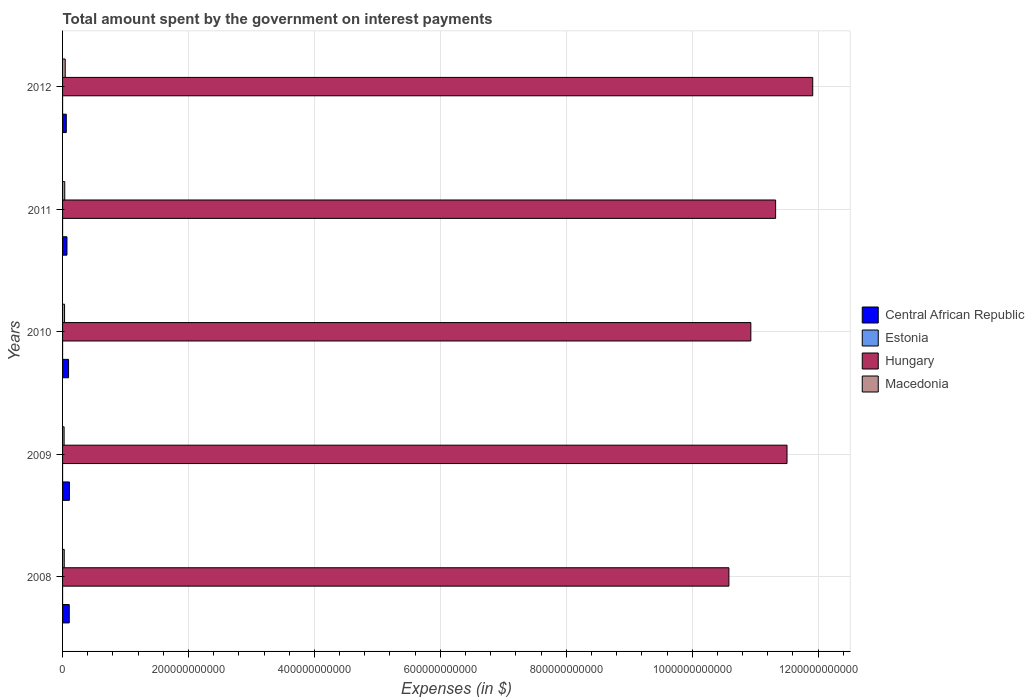Are the number of bars per tick equal to the number of legend labels?
Ensure brevity in your answer.  Yes. Are the number of bars on each tick of the Y-axis equal?
Your answer should be very brief. Yes. How many bars are there on the 2nd tick from the bottom?
Your answer should be very brief. 4. What is the label of the 1st group of bars from the top?
Your answer should be compact. 2012. In how many cases, is the number of bars for a given year not equal to the number of legend labels?
Provide a short and direct response. 0. What is the amount spent on interest payments by the government in Macedonia in 2011?
Offer a very short reply. 3.47e+09. Across all years, what is the maximum amount spent on interest payments by the government in Estonia?
Keep it short and to the point. 1.70e+07. Across all years, what is the minimum amount spent on interest payments by the government in Macedonia?
Give a very brief answer. 2.44e+09. In which year was the amount spent on interest payments by the government in Central African Republic minimum?
Offer a very short reply. 2012. What is the total amount spent on interest payments by the government in Hungary in the graph?
Your answer should be compact. 5.63e+12. What is the difference between the amount spent on interest payments by the government in Central African Republic in 2010 and that in 2012?
Provide a short and direct response. 3.59e+09. What is the difference between the amount spent on interest payments by the government in Central African Republic in 2010 and the amount spent on interest payments by the government in Macedonia in 2008?
Your answer should be compact. 6.87e+09. What is the average amount spent on interest payments by the government in Central African Republic per year?
Offer a very short reply. 8.77e+09. In the year 2010, what is the difference between the amount spent on interest payments by the government in Estonia and amount spent on interest payments by the government in Macedonia?
Provide a short and direct response. -3.17e+09. What is the ratio of the amount spent on interest payments by the government in Macedonia in 2008 to that in 2010?
Make the answer very short. 0.83. Is the amount spent on interest payments by the government in Macedonia in 2010 less than that in 2012?
Your answer should be compact. Yes. Is the difference between the amount spent on interest payments by the government in Estonia in 2010 and 2011 greater than the difference between the amount spent on interest payments by the government in Macedonia in 2010 and 2011?
Provide a short and direct response. Yes. What is the difference between the highest and the second highest amount spent on interest payments by the government in Central African Republic?
Provide a short and direct response. 2.10e+08. What is the difference between the highest and the lowest amount spent on interest payments by the government in Hungary?
Offer a terse response. 1.33e+11. In how many years, is the amount spent on interest payments by the government in Macedonia greater than the average amount spent on interest payments by the government in Macedonia taken over all years?
Give a very brief answer. 2. Is the sum of the amount spent on interest payments by the government in Central African Republic in 2008 and 2010 greater than the maximum amount spent on interest payments by the government in Macedonia across all years?
Offer a very short reply. Yes. What does the 2nd bar from the top in 2009 represents?
Your response must be concise. Hungary. What does the 4th bar from the bottom in 2010 represents?
Give a very brief answer. Macedonia. What is the difference between two consecutive major ticks on the X-axis?
Your answer should be compact. 2.00e+11. Does the graph contain any zero values?
Your answer should be very brief. No. How many legend labels are there?
Your answer should be very brief. 4. What is the title of the graph?
Offer a terse response. Total amount spent by the government on interest payments. Does "Denmark" appear as one of the legend labels in the graph?
Your response must be concise. No. What is the label or title of the X-axis?
Provide a succinct answer. Expenses (in $). What is the Expenses (in $) of Central African Republic in 2008?
Offer a very short reply. 1.06e+1. What is the Expenses (in $) of Estonia in 2008?
Provide a short and direct response. 1.32e+07. What is the Expenses (in $) in Hungary in 2008?
Provide a short and direct response. 1.06e+12. What is the Expenses (in $) in Macedonia in 2008?
Offer a very short reply. 2.65e+09. What is the Expenses (in $) of Central African Republic in 2009?
Ensure brevity in your answer.  1.08e+1. What is the Expenses (in $) of Estonia in 2009?
Your answer should be compact. 1.28e+07. What is the Expenses (in $) of Hungary in 2009?
Make the answer very short. 1.15e+12. What is the Expenses (in $) in Macedonia in 2009?
Provide a short and direct response. 2.44e+09. What is the Expenses (in $) of Central African Republic in 2010?
Provide a short and direct response. 9.51e+09. What is the Expenses (in $) of Estonia in 2010?
Provide a short and direct response. 8.20e+06. What is the Expenses (in $) in Hungary in 2010?
Give a very brief answer. 1.09e+12. What is the Expenses (in $) of Macedonia in 2010?
Your response must be concise. 3.17e+09. What is the Expenses (in $) of Central African Republic in 2011?
Give a very brief answer. 6.98e+09. What is the Expenses (in $) of Estonia in 2011?
Make the answer very short. 1.07e+07. What is the Expenses (in $) in Hungary in 2011?
Give a very brief answer. 1.13e+12. What is the Expenses (in $) of Macedonia in 2011?
Provide a short and direct response. 3.47e+09. What is the Expenses (in $) in Central African Republic in 2012?
Make the answer very short. 5.92e+09. What is the Expenses (in $) of Estonia in 2012?
Offer a very short reply. 1.70e+07. What is the Expenses (in $) in Hungary in 2012?
Provide a succinct answer. 1.19e+12. What is the Expenses (in $) of Macedonia in 2012?
Provide a succinct answer. 4.22e+09. Across all years, what is the maximum Expenses (in $) in Central African Republic?
Give a very brief answer. 1.08e+1. Across all years, what is the maximum Expenses (in $) in Estonia?
Ensure brevity in your answer.  1.70e+07. Across all years, what is the maximum Expenses (in $) in Hungary?
Provide a succinct answer. 1.19e+12. Across all years, what is the maximum Expenses (in $) in Macedonia?
Provide a short and direct response. 4.22e+09. Across all years, what is the minimum Expenses (in $) of Central African Republic?
Your answer should be very brief. 5.92e+09. Across all years, what is the minimum Expenses (in $) of Estonia?
Keep it short and to the point. 8.20e+06. Across all years, what is the minimum Expenses (in $) in Hungary?
Provide a short and direct response. 1.06e+12. Across all years, what is the minimum Expenses (in $) of Macedonia?
Provide a short and direct response. 2.44e+09. What is the total Expenses (in $) of Central African Republic in the graph?
Keep it short and to the point. 4.39e+1. What is the total Expenses (in $) of Estonia in the graph?
Your answer should be very brief. 6.19e+07. What is the total Expenses (in $) of Hungary in the graph?
Keep it short and to the point. 5.63e+12. What is the total Expenses (in $) of Macedonia in the graph?
Your answer should be compact. 1.60e+1. What is the difference between the Expenses (in $) in Central African Republic in 2008 and that in 2009?
Your answer should be compact. -2.10e+08. What is the difference between the Expenses (in $) in Hungary in 2008 and that in 2009?
Ensure brevity in your answer.  -9.23e+1. What is the difference between the Expenses (in $) in Macedonia in 2008 and that in 2009?
Your answer should be very brief. 2.01e+08. What is the difference between the Expenses (in $) in Central African Republic in 2008 and that in 2010?
Keep it short and to the point. 1.11e+09. What is the difference between the Expenses (in $) of Hungary in 2008 and that in 2010?
Your answer should be compact. -3.49e+1. What is the difference between the Expenses (in $) of Macedonia in 2008 and that in 2010?
Your answer should be very brief. -5.28e+08. What is the difference between the Expenses (in $) in Central African Republic in 2008 and that in 2011?
Provide a succinct answer. 3.64e+09. What is the difference between the Expenses (in $) of Estonia in 2008 and that in 2011?
Make the answer very short. 2.50e+06. What is the difference between the Expenses (in $) in Hungary in 2008 and that in 2011?
Offer a very short reply. -7.42e+1. What is the difference between the Expenses (in $) of Macedonia in 2008 and that in 2011?
Give a very brief answer. -8.25e+08. What is the difference between the Expenses (in $) of Central African Republic in 2008 and that in 2012?
Keep it short and to the point. 4.70e+09. What is the difference between the Expenses (in $) of Estonia in 2008 and that in 2012?
Make the answer very short. -3.80e+06. What is the difference between the Expenses (in $) in Hungary in 2008 and that in 2012?
Your response must be concise. -1.33e+11. What is the difference between the Expenses (in $) in Macedonia in 2008 and that in 2012?
Provide a succinct answer. -1.57e+09. What is the difference between the Expenses (in $) in Central African Republic in 2009 and that in 2010?
Your response must be concise. 1.32e+09. What is the difference between the Expenses (in $) in Estonia in 2009 and that in 2010?
Your response must be concise. 4.60e+06. What is the difference between the Expenses (in $) of Hungary in 2009 and that in 2010?
Make the answer very short. 5.74e+1. What is the difference between the Expenses (in $) in Macedonia in 2009 and that in 2010?
Provide a succinct answer. -7.29e+08. What is the difference between the Expenses (in $) of Central African Republic in 2009 and that in 2011?
Keep it short and to the point. 3.85e+09. What is the difference between the Expenses (in $) of Estonia in 2009 and that in 2011?
Ensure brevity in your answer.  2.10e+06. What is the difference between the Expenses (in $) in Hungary in 2009 and that in 2011?
Offer a terse response. 1.81e+1. What is the difference between the Expenses (in $) of Macedonia in 2009 and that in 2011?
Ensure brevity in your answer.  -1.03e+09. What is the difference between the Expenses (in $) of Central African Republic in 2009 and that in 2012?
Provide a succinct answer. 4.91e+09. What is the difference between the Expenses (in $) of Estonia in 2009 and that in 2012?
Keep it short and to the point. -4.20e+06. What is the difference between the Expenses (in $) of Hungary in 2009 and that in 2012?
Ensure brevity in your answer.  -4.08e+1. What is the difference between the Expenses (in $) of Macedonia in 2009 and that in 2012?
Make the answer very short. -1.77e+09. What is the difference between the Expenses (in $) of Central African Republic in 2010 and that in 2011?
Your response must be concise. 2.53e+09. What is the difference between the Expenses (in $) in Estonia in 2010 and that in 2011?
Provide a short and direct response. -2.50e+06. What is the difference between the Expenses (in $) in Hungary in 2010 and that in 2011?
Provide a succinct answer. -3.94e+1. What is the difference between the Expenses (in $) of Macedonia in 2010 and that in 2011?
Offer a terse response. -2.97e+08. What is the difference between the Expenses (in $) in Central African Republic in 2010 and that in 2012?
Ensure brevity in your answer.  3.59e+09. What is the difference between the Expenses (in $) of Estonia in 2010 and that in 2012?
Provide a succinct answer. -8.80e+06. What is the difference between the Expenses (in $) of Hungary in 2010 and that in 2012?
Keep it short and to the point. -9.83e+1. What is the difference between the Expenses (in $) of Macedonia in 2010 and that in 2012?
Make the answer very short. -1.04e+09. What is the difference between the Expenses (in $) of Central African Republic in 2011 and that in 2012?
Your response must be concise. 1.06e+09. What is the difference between the Expenses (in $) of Estonia in 2011 and that in 2012?
Ensure brevity in your answer.  -6.30e+06. What is the difference between the Expenses (in $) of Hungary in 2011 and that in 2012?
Make the answer very short. -5.89e+1. What is the difference between the Expenses (in $) of Macedonia in 2011 and that in 2012?
Make the answer very short. -7.45e+08. What is the difference between the Expenses (in $) in Central African Republic in 2008 and the Expenses (in $) in Estonia in 2009?
Provide a succinct answer. 1.06e+1. What is the difference between the Expenses (in $) of Central African Republic in 2008 and the Expenses (in $) of Hungary in 2009?
Your answer should be compact. -1.14e+12. What is the difference between the Expenses (in $) of Central African Republic in 2008 and the Expenses (in $) of Macedonia in 2009?
Your response must be concise. 8.18e+09. What is the difference between the Expenses (in $) in Estonia in 2008 and the Expenses (in $) in Hungary in 2009?
Keep it short and to the point. -1.15e+12. What is the difference between the Expenses (in $) in Estonia in 2008 and the Expenses (in $) in Macedonia in 2009?
Ensure brevity in your answer.  -2.43e+09. What is the difference between the Expenses (in $) in Hungary in 2008 and the Expenses (in $) in Macedonia in 2009?
Your response must be concise. 1.06e+12. What is the difference between the Expenses (in $) in Central African Republic in 2008 and the Expenses (in $) in Estonia in 2010?
Your answer should be compact. 1.06e+1. What is the difference between the Expenses (in $) of Central African Republic in 2008 and the Expenses (in $) of Hungary in 2010?
Give a very brief answer. -1.08e+12. What is the difference between the Expenses (in $) of Central African Republic in 2008 and the Expenses (in $) of Macedonia in 2010?
Your answer should be very brief. 7.45e+09. What is the difference between the Expenses (in $) in Estonia in 2008 and the Expenses (in $) in Hungary in 2010?
Offer a very short reply. -1.09e+12. What is the difference between the Expenses (in $) of Estonia in 2008 and the Expenses (in $) of Macedonia in 2010?
Keep it short and to the point. -3.16e+09. What is the difference between the Expenses (in $) in Hungary in 2008 and the Expenses (in $) in Macedonia in 2010?
Your answer should be compact. 1.06e+12. What is the difference between the Expenses (in $) of Central African Republic in 2008 and the Expenses (in $) of Estonia in 2011?
Your answer should be compact. 1.06e+1. What is the difference between the Expenses (in $) in Central African Republic in 2008 and the Expenses (in $) in Hungary in 2011?
Make the answer very short. -1.12e+12. What is the difference between the Expenses (in $) of Central African Republic in 2008 and the Expenses (in $) of Macedonia in 2011?
Provide a short and direct response. 7.15e+09. What is the difference between the Expenses (in $) of Estonia in 2008 and the Expenses (in $) of Hungary in 2011?
Provide a short and direct response. -1.13e+12. What is the difference between the Expenses (in $) in Estonia in 2008 and the Expenses (in $) in Macedonia in 2011?
Provide a succinct answer. -3.46e+09. What is the difference between the Expenses (in $) in Hungary in 2008 and the Expenses (in $) in Macedonia in 2011?
Keep it short and to the point. 1.05e+12. What is the difference between the Expenses (in $) of Central African Republic in 2008 and the Expenses (in $) of Estonia in 2012?
Offer a terse response. 1.06e+1. What is the difference between the Expenses (in $) of Central African Republic in 2008 and the Expenses (in $) of Hungary in 2012?
Offer a very short reply. -1.18e+12. What is the difference between the Expenses (in $) in Central African Republic in 2008 and the Expenses (in $) in Macedonia in 2012?
Provide a succinct answer. 6.41e+09. What is the difference between the Expenses (in $) of Estonia in 2008 and the Expenses (in $) of Hungary in 2012?
Provide a short and direct response. -1.19e+12. What is the difference between the Expenses (in $) of Estonia in 2008 and the Expenses (in $) of Macedonia in 2012?
Make the answer very short. -4.20e+09. What is the difference between the Expenses (in $) of Hungary in 2008 and the Expenses (in $) of Macedonia in 2012?
Provide a short and direct response. 1.05e+12. What is the difference between the Expenses (in $) in Central African Republic in 2009 and the Expenses (in $) in Estonia in 2010?
Your response must be concise. 1.08e+1. What is the difference between the Expenses (in $) of Central African Republic in 2009 and the Expenses (in $) of Hungary in 2010?
Make the answer very short. -1.08e+12. What is the difference between the Expenses (in $) in Central African Republic in 2009 and the Expenses (in $) in Macedonia in 2010?
Give a very brief answer. 7.66e+09. What is the difference between the Expenses (in $) of Estonia in 2009 and the Expenses (in $) of Hungary in 2010?
Make the answer very short. -1.09e+12. What is the difference between the Expenses (in $) of Estonia in 2009 and the Expenses (in $) of Macedonia in 2010?
Make the answer very short. -3.16e+09. What is the difference between the Expenses (in $) of Hungary in 2009 and the Expenses (in $) of Macedonia in 2010?
Ensure brevity in your answer.  1.15e+12. What is the difference between the Expenses (in $) in Central African Republic in 2009 and the Expenses (in $) in Estonia in 2011?
Offer a very short reply. 1.08e+1. What is the difference between the Expenses (in $) of Central African Republic in 2009 and the Expenses (in $) of Hungary in 2011?
Provide a short and direct response. -1.12e+12. What is the difference between the Expenses (in $) in Central African Republic in 2009 and the Expenses (in $) in Macedonia in 2011?
Provide a succinct answer. 7.36e+09. What is the difference between the Expenses (in $) in Estonia in 2009 and the Expenses (in $) in Hungary in 2011?
Offer a very short reply. -1.13e+12. What is the difference between the Expenses (in $) of Estonia in 2009 and the Expenses (in $) of Macedonia in 2011?
Your answer should be compact. -3.46e+09. What is the difference between the Expenses (in $) in Hungary in 2009 and the Expenses (in $) in Macedonia in 2011?
Keep it short and to the point. 1.15e+12. What is the difference between the Expenses (in $) in Central African Republic in 2009 and the Expenses (in $) in Estonia in 2012?
Your response must be concise. 1.08e+1. What is the difference between the Expenses (in $) of Central African Republic in 2009 and the Expenses (in $) of Hungary in 2012?
Provide a short and direct response. -1.18e+12. What is the difference between the Expenses (in $) in Central African Republic in 2009 and the Expenses (in $) in Macedonia in 2012?
Offer a very short reply. 6.62e+09. What is the difference between the Expenses (in $) of Estonia in 2009 and the Expenses (in $) of Hungary in 2012?
Your answer should be very brief. -1.19e+12. What is the difference between the Expenses (in $) in Estonia in 2009 and the Expenses (in $) in Macedonia in 2012?
Provide a succinct answer. -4.20e+09. What is the difference between the Expenses (in $) in Hungary in 2009 and the Expenses (in $) in Macedonia in 2012?
Provide a succinct answer. 1.15e+12. What is the difference between the Expenses (in $) in Central African Republic in 2010 and the Expenses (in $) in Estonia in 2011?
Keep it short and to the point. 9.50e+09. What is the difference between the Expenses (in $) of Central African Republic in 2010 and the Expenses (in $) of Hungary in 2011?
Provide a succinct answer. -1.12e+12. What is the difference between the Expenses (in $) in Central African Republic in 2010 and the Expenses (in $) in Macedonia in 2011?
Offer a very short reply. 6.04e+09. What is the difference between the Expenses (in $) of Estonia in 2010 and the Expenses (in $) of Hungary in 2011?
Make the answer very short. -1.13e+12. What is the difference between the Expenses (in $) in Estonia in 2010 and the Expenses (in $) in Macedonia in 2011?
Keep it short and to the point. -3.46e+09. What is the difference between the Expenses (in $) of Hungary in 2010 and the Expenses (in $) of Macedonia in 2011?
Make the answer very short. 1.09e+12. What is the difference between the Expenses (in $) of Central African Republic in 2010 and the Expenses (in $) of Estonia in 2012?
Ensure brevity in your answer.  9.49e+09. What is the difference between the Expenses (in $) in Central African Republic in 2010 and the Expenses (in $) in Hungary in 2012?
Offer a very short reply. -1.18e+12. What is the difference between the Expenses (in $) in Central African Republic in 2010 and the Expenses (in $) in Macedonia in 2012?
Your answer should be very brief. 5.30e+09. What is the difference between the Expenses (in $) in Estonia in 2010 and the Expenses (in $) in Hungary in 2012?
Offer a very short reply. -1.19e+12. What is the difference between the Expenses (in $) of Estonia in 2010 and the Expenses (in $) of Macedonia in 2012?
Provide a succinct answer. -4.21e+09. What is the difference between the Expenses (in $) of Hungary in 2010 and the Expenses (in $) of Macedonia in 2012?
Offer a terse response. 1.09e+12. What is the difference between the Expenses (in $) in Central African Republic in 2011 and the Expenses (in $) in Estonia in 2012?
Your answer should be very brief. 6.97e+09. What is the difference between the Expenses (in $) of Central African Republic in 2011 and the Expenses (in $) of Hungary in 2012?
Your answer should be very brief. -1.18e+12. What is the difference between the Expenses (in $) in Central African Republic in 2011 and the Expenses (in $) in Macedonia in 2012?
Provide a short and direct response. 2.77e+09. What is the difference between the Expenses (in $) in Estonia in 2011 and the Expenses (in $) in Hungary in 2012?
Provide a short and direct response. -1.19e+12. What is the difference between the Expenses (in $) in Estonia in 2011 and the Expenses (in $) in Macedonia in 2012?
Provide a short and direct response. -4.21e+09. What is the difference between the Expenses (in $) of Hungary in 2011 and the Expenses (in $) of Macedonia in 2012?
Your response must be concise. 1.13e+12. What is the average Expenses (in $) of Central African Republic per year?
Provide a short and direct response. 8.77e+09. What is the average Expenses (in $) of Estonia per year?
Offer a very short reply. 1.24e+07. What is the average Expenses (in $) in Hungary per year?
Provide a short and direct response. 1.13e+12. What is the average Expenses (in $) in Macedonia per year?
Ensure brevity in your answer.  3.19e+09. In the year 2008, what is the difference between the Expenses (in $) of Central African Republic and Expenses (in $) of Estonia?
Your answer should be very brief. 1.06e+1. In the year 2008, what is the difference between the Expenses (in $) of Central African Republic and Expenses (in $) of Hungary?
Provide a short and direct response. -1.05e+12. In the year 2008, what is the difference between the Expenses (in $) of Central African Republic and Expenses (in $) of Macedonia?
Give a very brief answer. 7.98e+09. In the year 2008, what is the difference between the Expenses (in $) in Estonia and Expenses (in $) in Hungary?
Ensure brevity in your answer.  -1.06e+12. In the year 2008, what is the difference between the Expenses (in $) in Estonia and Expenses (in $) in Macedonia?
Provide a succinct answer. -2.63e+09. In the year 2008, what is the difference between the Expenses (in $) of Hungary and Expenses (in $) of Macedonia?
Give a very brief answer. 1.06e+12. In the year 2009, what is the difference between the Expenses (in $) of Central African Republic and Expenses (in $) of Estonia?
Make the answer very short. 1.08e+1. In the year 2009, what is the difference between the Expenses (in $) in Central African Republic and Expenses (in $) in Hungary?
Provide a succinct answer. -1.14e+12. In the year 2009, what is the difference between the Expenses (in $) of Central African Republic and Expenses (in $) of Macedonia?
Your answer should be very brief. 8.39e+09. In the year 2009, what is the difference between the Expenses (in $) of Estonia and Expenses (in $) of Hungary?
Make the answer very short. -1.15e+12. In the year 2009, what is the difference between the Expenses (in $) of Estonia and Expenses (in $) of Macedonia?
Provide a short and direct response. -2.43e+09. In the year 2009, what is the difference between the Expenses (in $) in Hungary and Expenses (in $) in Macedonia?
Your answer should be compact. 1.15e+12. In the year 2010, what is the difference between the Expenses (in $) of Central African Republic and Expenses (in $) of Estonia?
Provide a short and direct response. 9.50e+09. In the year 2010, what is the difference between the Expenses (in $) in Central African Republic and Expenses (in $) in Hungary?
Offer a terse response. -1.08e+12. In the year 2010, what is the difference between the Expenses (in $) in Central African Republic and Expenses (in $) in Macedonia?
Offer a terse response. 6.34e+09. In the year 2010, what is the difference between the Expenses (in $) of Estonia and Expenses (in $) of Hungary?
Offer a terse response. -1.09e+12. In the year 2010, what is the difference between the Expenses (in $) in Estonia and Expenses (in $) in Macedonia?
Your answer should be very brief. -3.17e+09. In the year 2010, what is the difference between the Expenses (in $) in Hungary and Expenses (in $) in Macedonia?
Ensure brevity in your answer.  1.09e+12. In the year 2011, what is the difference between the Expenses (in $) in Central African Republic and Expenses (in $) in Estonia?
Provide a succinct answer. 6.97e+09. In the year 2011, what is the difference between the Expenses (in $) in Central African Republic and Expenses (in $) in Hungary?
Offer a very short reply. -1.13e+12. In the year 2011, what is the difference between the Expenses (in $) of Central African Republic and Expenses (in $) of Macedonia?
Your answer should be very brief. 3.51e+09. In the year 2011, what is the difference between the Expenses (in $) of Estonia and Expenses (in $) of Hungary?
Keep it short and to the point. -1.13e+12. In the year 2011, what is the difference between the Expenses (in $) in Estonia and Expenses (in $) in Macedonia?
Provide a succinct answer. -3.46e+09. In the year 2011, what is the difference between the Expenses (in $) in Hungary and Expenses (in $) in Macedonia?
Provide a succinct answer. 1.13e+12. In the year 2012, what is the difference between the Expenses (in $) of Central African Republic and Expenses (in $) of Estonia?
Provide a short and direct response. 5.91e+09. In the year 2012, what is the difference between the Expenses (in $) of Central African Republic and Expenses (in $) of Hungary?
Ensure brevity in your answer.  -1.19e+12. In the year 2012, what is the difference between the Expenses (in $) in Central African Republic and Expenses (in $) in Macedonia?
Keep it short and to the point. 1.71e+09. In the year 2012, what is the difference between the Expenses (in $) in Estonia and Expenses (in $) in Hungary?
Make the answer very short. -1.19e+12. In the year 2012, what is the difference between the Expenses (in $) in Estonia and Expenses (in $) in Macedonia?
Provide a short and direct response. -4.20e+09. In the year 2012, what is the difference between the Expenses (in $) of Hungary and Expenses (in $) of Macedonia?
Make the answer very short. 1.19e+12. What is the ratio of the Expenses (in $) in Central African Republic in 2008 to that in 2009?
Provide a short and direct response. 0.98. What is the ratio of the Expenses (in $) in Estonia in 2008 to that in 2009?
Ensure brevity in your answer.  1.03. What is the ratio of the Expenses (in $) of Hungary in 2008 to that in 2009?
Ensure brevity in your answer.  0.92. What is the ratio of the Expenses (in $) in Macedonia in 2008 to that in 2009?
Your answer should be compact. 1.08. What is the ratio of the Expenses (in $) of Central African Republic in 2008 to that in 2010?
Offer a terse response. 1.12. What is the ratio of the Expenses (in $) of Estonia in 2008 to that in 2010?
Provide a short and direct response. 1.61. What is the ratio of the Expenses (in $) of Hungary in 2008 to that in 2010?
Your response must be concise. 0.97. What is the ratio of the Expenses (in $) in Macedonia in 2008 to that in 2010?
Make the answer very short. 0.83. What is the ratio of the Expenses (in $) in Central African Republic in 2008 to that in 2011?
Your answer should be compact. 1.52. What is the ratio of the Expenses (in $) in Estonia in 2008 to that in 2011?
Keep it short and to the point. 1.23. What is the ratio of the Expenses (in $) in Hungary in 2008 to that in 2011?
Keep it short and to the point. 0.93. What is the ratio of the Expenses (in $) of Macedonia in 2008 to that in 2011?
Keep it short and to the point. 0.76. What is the ratio of the Expenses (in $) in Central African Republic in 2008 to that in 2012?
Give a very brief answer. 1.79. What is the ratio of the Expenses (in $) of Estonia in 2008 to that in 2012?
Provide a succinct answer. 0.78. What is the ratio of the Expenses (in $) of Hungary in 2008 to that in 2012?
Ensure brevity in your answer.  0.89. What is the ratio of the Expenses (in $) in Macedonia in 2008 to that in 2012?
Provide a succinct answer. 0.63. What is the ratio of the Expenses (in $) in Central African Republic in 2009 to that in 2010?
Offer a terse response. 1.14. What is the ratio of the Expenses (in $) of Estonia in 2009 to that in 2010?
Provide a succinct answer. 1.56. What is the ratio of the Expenses (in $) of Hungary in 2009 to that in 2010?
Your answer should be very brief. 1.05. What is the ratio of the Expenses (in $) of Macedonia in 2009 to that in 2010?
Keep it short and to the point. 0.77. What is the ratio of the Expenses (in $) of Central African Republic in 2009 to that in 2011?
Your answer should be very brief. 1.55. What is the ratio of the Expenses (in $) of Estonia in 2009 to that in 2011?
Ensure brevity in your answer.  1.2. What is the ratio of the Expenses (in $) of Hungary in 2009 to that in 2011?
Keep it short and to the point. 1.02. What is the ratio of the Expenses (in $) in Macedonia in 2009 to that in 2011?
Give a very brief answer. 0.7. What is the ratio of the Expenses (in $) in Central African Republic in 2009 to that in 2012?
Offer a very short reply. 1.83. What is the ratio of the Expenses (in $) in Estonia in 2009 to that in 2012?
Offer a very short reply. 0.75. What is the ratio of the Expenses (in $) of Hungary in 2009 to that in 2012?
Make the answer very short. 0.97. What is the ratio of the Expenses (in $) of Macedonia in 2009 to that in 2012?
Make the answer very short. 0.58. What is the ratio of the Expenses (in $) in Central African Republic in 2010 to that in 2011?
Keep it short and to the point. 1.36. What is the ratio of the Expenses (in $) of Estonia in 2010 to that in 2011?
Make the answer very short. 0.77. What is the ratio of the Expenses (in $) of Hungary in 2010 to that in 2011?
Give a very brief answer. 0.97. What is the ratio of the Expenses (in $) of Macedonia in 2010 to that in 2011?
Make the answer very short. 0.91. What is the ratio of the Expenses (in $) in Central African Republic in 2010 to that in 2012?
Ensure brevity in your answer.  1.61. What is the ratio of the Expenses (in $) in Estonia in 2010 to that in 2012?
Your response must be concise. 0.48. What is the ratio of the Expenses (in $) of Hungary in 2010 to that in 2012?
Keep it short and to the point. 0.92. What is the ratio of the Expenses (in $) of Macedonia in 2010 to that in 2012?
Keep it short and to the point. 0.75. What is the ratio of the Expenses (in $) in Central African Republic in 2011 to that in 2012?
Make the answer very short. 1.18. What is the ratio of the Expenses (in $) in Estonia in 2011 to that in 2012?
Provide a succinct answer. 0.63. What is the ratio of the Expenses (in $) in Hungary in 2011 to that in 2012?
Your answer should be very brief. 0.95. What is the ratio of the Expenses (in $) of Macedonia in 2011 to that in 2012?
Make the answer very short. 0.82. What is the difference between the highest and the second highest Expenses (in $) of Central African Republic?
Give a very brief answer. 2.10e+08. What is the difference between the highest and the second highest Expenses (in $) in Estonia?
Keep it short and to the point. 3.80e+06. What is the difference between the highest and the second highest Expenses (in $) in Hungary?
Keep it short and to the point. 4.08e+1. What is the difference between the highest and the second highest Expenses (in $) in Macedonia?
Provide a succinct answer. 7.45e+08. What is the difference between the highest and the lowest Expenses (in $) in Central African Republic?
Offer a terse response. 4.91e+09. What is the difference between the highest and the lowest Expenses (in $) in Estonia?
Ensure brevity in your answer.  8.80e+06. What is the difference between the highest and the lowest Expenses (in $) in Hungary?
Provide a succinct answer. 1.33e+11. What is the difference between the highest and the lowest Expenses (in $) in Macedonia?
Offer a terse response. 1.77e+09. 